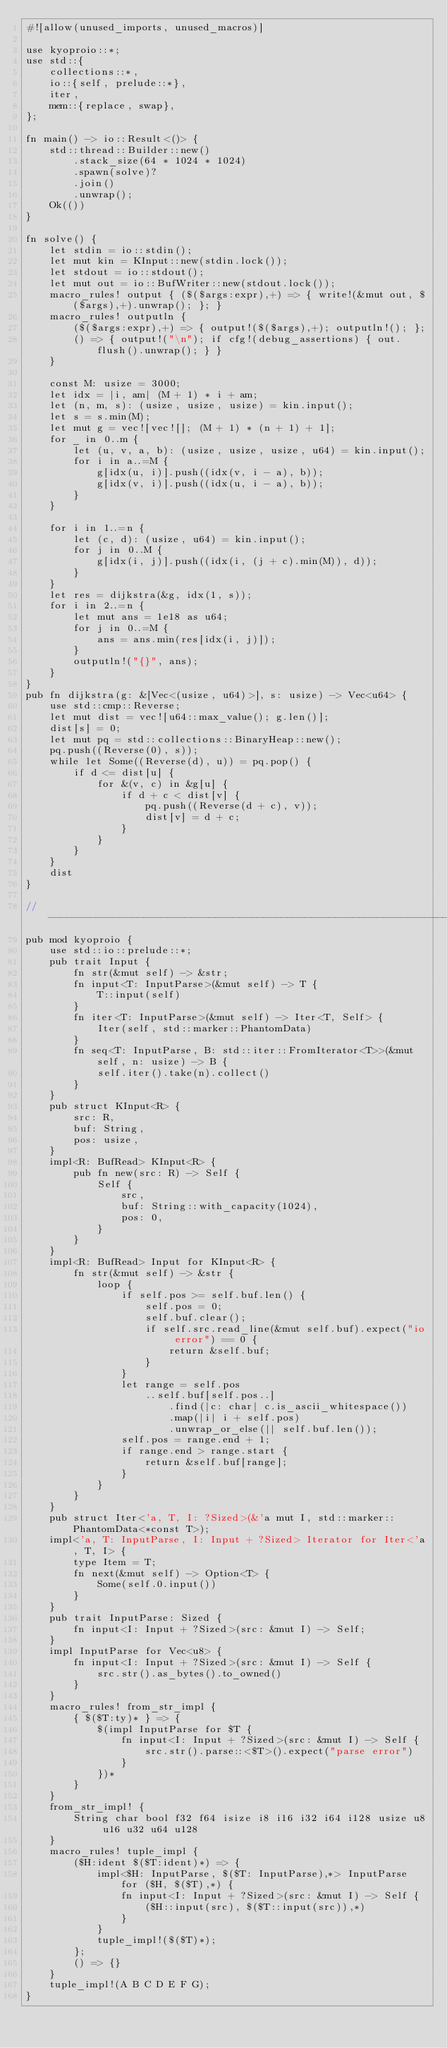<code> <loc_0><loc_0><loc_500><loc_500><_Rust_>#![allow(unused_imports, unused_macros)]

use kyoproio::*;
use std::{
    collections::*,
    io::{self, prelude::*},
    iter,
    mem::{replace, swap},
};

fn main() -> io::Result<()> {
    std::thread::Builder::new()
        .stack_size(64 * 1024 * 1024)
        .spawn(solve)?
        .join()
        .unwrap();
    Ok(())
}

fn solve() {
    let stdin = io::stdin();
    let mut kin = KInput::new(stdin.lock());
    let stdout = io::stdout();
    let mut out = io::BufWriter::new(stdout.lock());
    macro_rules! output { ($($args:expr),+) => { write!(&mut out, $($args),+).unwrap(); }; }
    macro_rules! outputln {
        ($($args:expr),+) => { output!($($args),+); outputln!(); };
        () => { output!("\n"); if cfg!(debug_assertions) { out.flush().unwrap(); } }
    }

    const M: usize = 3000;
    let idx = |i, am| (M + 1) * i + am;
    let (n, m, s): (usize, usize, usize) = kin.input();
    let s = s.min(M);
    let mut g = vec![vec![]; (M + 1) * (n + 1) + 1];
    for _ in 0..m {
        let (u, v, a, b): (usize, usize, usize, u64) = kin.input();
        for i in a..=M {
            g[idx(u, i)].push((idx(v, i - a), b));
            g[idx(v, i)].push((idx(u, i - a), b));
        }
    }
    
    for i in 1..=n {
        let (c, d): (usize, u64) = kin.input();
        for j in 0..M {
            g[idx(i, j)].push((idx(i, (j + c).min(M)), d));
        }
    }
    let res = dijkstra(&g, idx(1, s));
    for i in 2..=n {
        let mut ans = 1e18 as u64;
        for j in 0..=M {
            ans = ans.min(res[idx(i, j)]);
        }
        outputln!("{}", ans);
    }
}
pub fn dijkstra(g: &[Vec<(usize, u64)>], s: usize) -> Vec<u64> {
    use std::cmp::Reverse;
    let mut dist = vec![u64::max_value(); g.len()];
    dist[s] = 0;
    let mut pq = std::collections::BinaryHeap::new();
    pq.push((Reverse(0), s));
    while let Some((Reverse(d), u)) = pq.pop() {
        if d <= dist[u] {
            for &(v, c) in &g[u] {
                if d + c < dist[v] {
                    pq.push((Reverse(d + c), v));
                    dist[v] = d + c;
                }
            }
        }
    }
    dist
}

// -----------------------------------------------------------------------------
pub mod kyoproio {
    use std::io::prelude::*;
    pub trait Input {
        fn str(&mut self) -> &str;
        fn input<T: InputParse>(&mut self) -> T {
            T::input(self)
        }
        fn iter<T: InputParse>(&mut self) -> Iter<T, Self> {
            Iter(self, std::marker::PhantomData)
        }
        fn seq<T: InputParse, B: std::iter::FromIterator<T>>(&mut self, n: usize) -> B {
            self.iter().take(n).collect()
        }
    }
    pub struct KInput<R> {
        src: R,
        buf: String,
        pos: usize,
    }
    impl<R: BufRead> KInput<R> {
        pub fn new(src: R) -> Self {
            Self {
                src,
                buf: String::with_capacity(1024),
                pos: 0,
            }
        }
    }
    impl<R: BufRead> Input for KInput<R> {
        fn str(&mut self) -> &str {
            loop {
                if self.pos >= self.buf.len() {
                    self.pos = 0;
                    self.buf.clear();
                    if self.src.read_line(&mut self.buf).expect("io error") == 0 {
                        return &self.buf;
                    }
                }
                let range = self.pos
                    ..self.buf[self.pos..]
                        .find(|c: char| c.is_ascii_whitespace())
                        .map(|i| i + self.pos)
                        .unwrap_or_else(|| self.buf.len());
                self.pos = range.end + 1;
                if range.end > range.start {
                    return &self.buf[range];
                }
            }
        }
    }
    pub struct Iter<'a, T, I: ?Sized>(&'a mut I, std::marker::PhantomData<*const T>);
    impl<'a, T: InputParse, I: Input + ?Sized> Iterator for Iter<'a, T, I> {
        type Item = T;
        fn next(&mut self) -> Option<T> {
            Some(self.0.input())
        }
    }
    pub trait InputParse: Sized {
        fn input<I: Input + ?Sized>(src: &mut I) -> Self;
    }
    impl InputParse for Vec<u8> {
        fn input<I: Input + ?Sized>(src: &mut I) -> Self {
            src.str().as_bytes().to_owned()
        }
    }
    macro_rules! from_str_impl {
        { $($T:ty)* } => {
            $(impl InputParse for $T {
                fn input<I: Input + ?Sized>(src: &mut I) -> Self {
                    src.str().parse::<$T>().expect("parse error")
                }
            })*
        }
    }
    from_str_impl! {
        String char bool f32 f64 isize i8 i16 i32 i64 i128 usize u8 u16 u32 u64 u128
    }
    macro_rules! tuple_impl {
        ($H:ident $($T:ident)*) => {
            impl<$H: InputParse, $($T: InputParse),*> InputParse for ($H, $($T),*) {
                fn input<I: Input + ?Sized>(src: &mut I) -> Self {
                    ($H::input(src), $($T::input(src)),*)
                }
            }
            tuple_impl!($($T)*);
        };
        () => {}
    }
    tuple_impl!(A B C D E F G);
}
</code> 